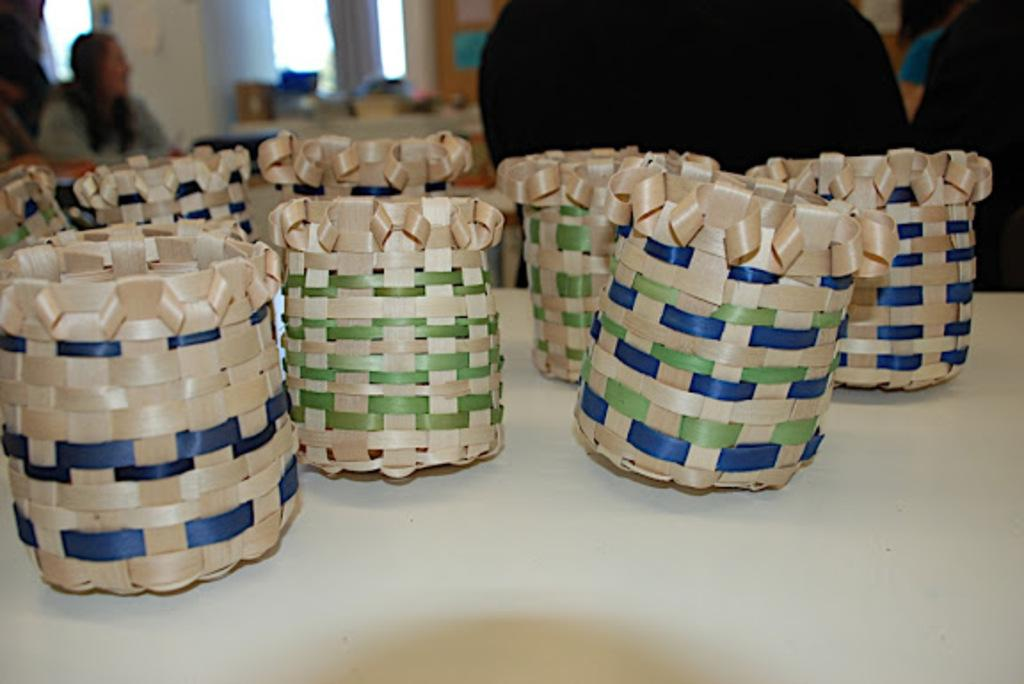What is the main piece of furniture in the image? There is a table in the image. What is placed on the table? There are baskets on the table. Can you describe the background of the image? There are persons visible in the background, along with a window, another table, and other objects. What type of quilt is being used to smash the tooth in the image? There is no quilt or tooth present in the image, and therefore no such activity can be observed. 